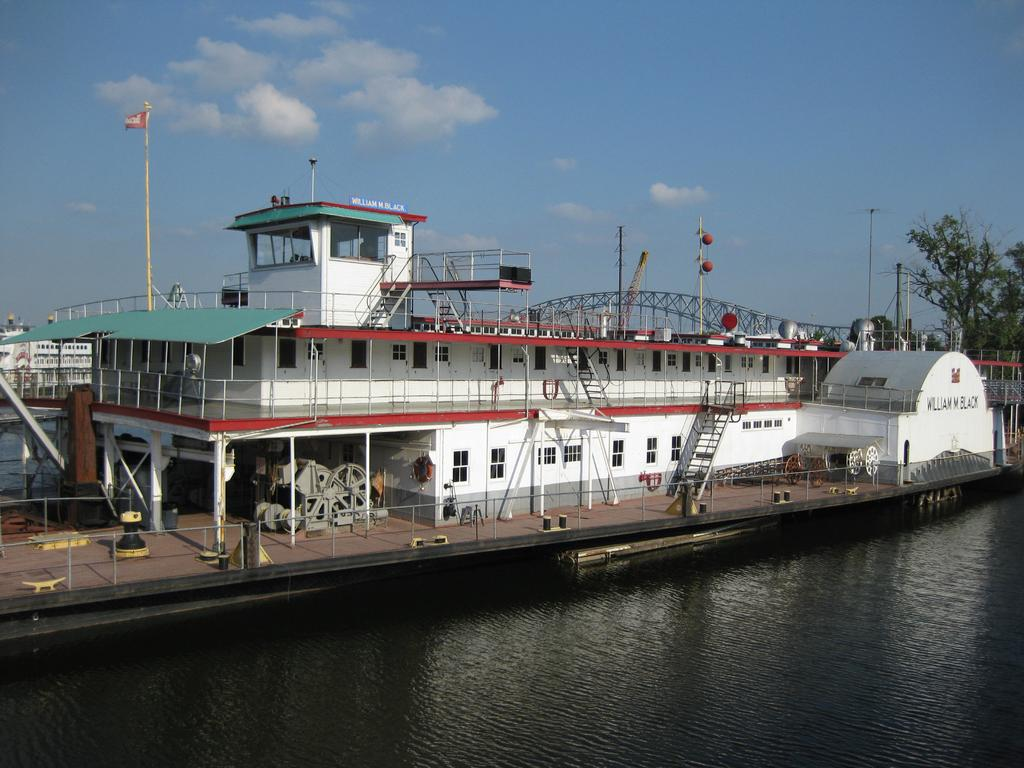What type of vehicles can be seen in the water in the image? There are ships in the water in the image. What structure is present in the image? There is a flag pole in the image. What type of natural vegetation is visible in the image? There are trees in the image. What architectural feature can be seen in the image? There is a bridge in the image. What color is the sky in the image? The sky is blue and visible at the top of the image. What type of body of water might the image be near? The image may have been taken near a lake. Where is the wheel located in the image? There is no wheel present in the image. What type of sink can be seen in the image? There is no sink present in the image. 